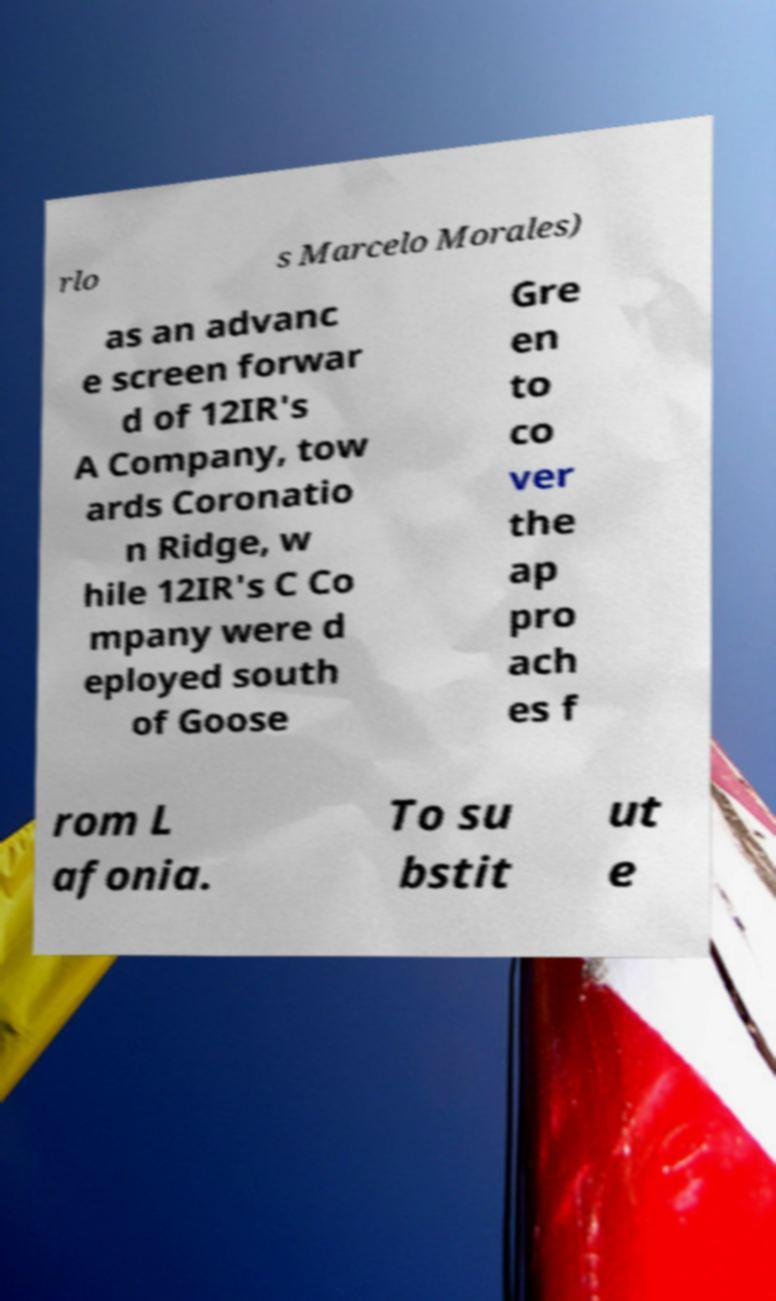Please read and relay the text visible in this image. What does it say? rlo s Marcelo Morales) as an advanc e screen forwar d of 12IR's A Company, tow ards Coronatio n Ridge, w hile 12IR's C Co mpany were d eployed south of Goose Gre en to co ver the ap pro ach es f rom L afonia. To su bstit ut e 